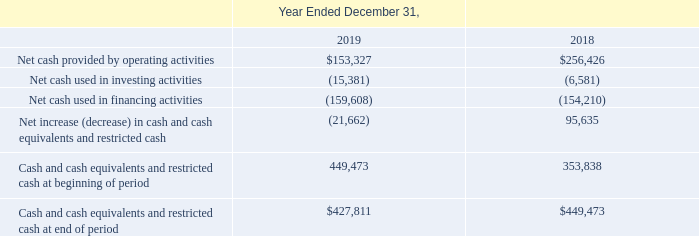GreenSky, Inc. NOTES TO CONSOLIDATED FINANCIAL STATEMENTS — (Continued) (United States Dollars in thousands, except per share data, unless otherwise stated)
The following table reflects the cash flow impact of GS Holdings on the Consolidated Statements of Cash Flows for the years indicated.
Which years does the table show? 2019, 2018. What was the Net cash provided by operating activities in 2019?
Answer scale should be: thousand. 153,327. What was the Net cash used in financing activities in 2019?
Answer scale should be: thousand. (159,608). Which years did Cash and cash equivalents and restricted cash at beginning of period exceed $400,000 thousand? 2019
Answer: 1. What was the change in the net cash used in financing activities between 2018 and 2019?
Answer scale should be: thousand. -159,608-(-154,210)
Answer: -5398. What was the percentage change in Net cash provided by operating activities between 2018 and 2019?
Answer scale should be: percent. (153,327-256,426)/256,426
Answer: -40.21. 